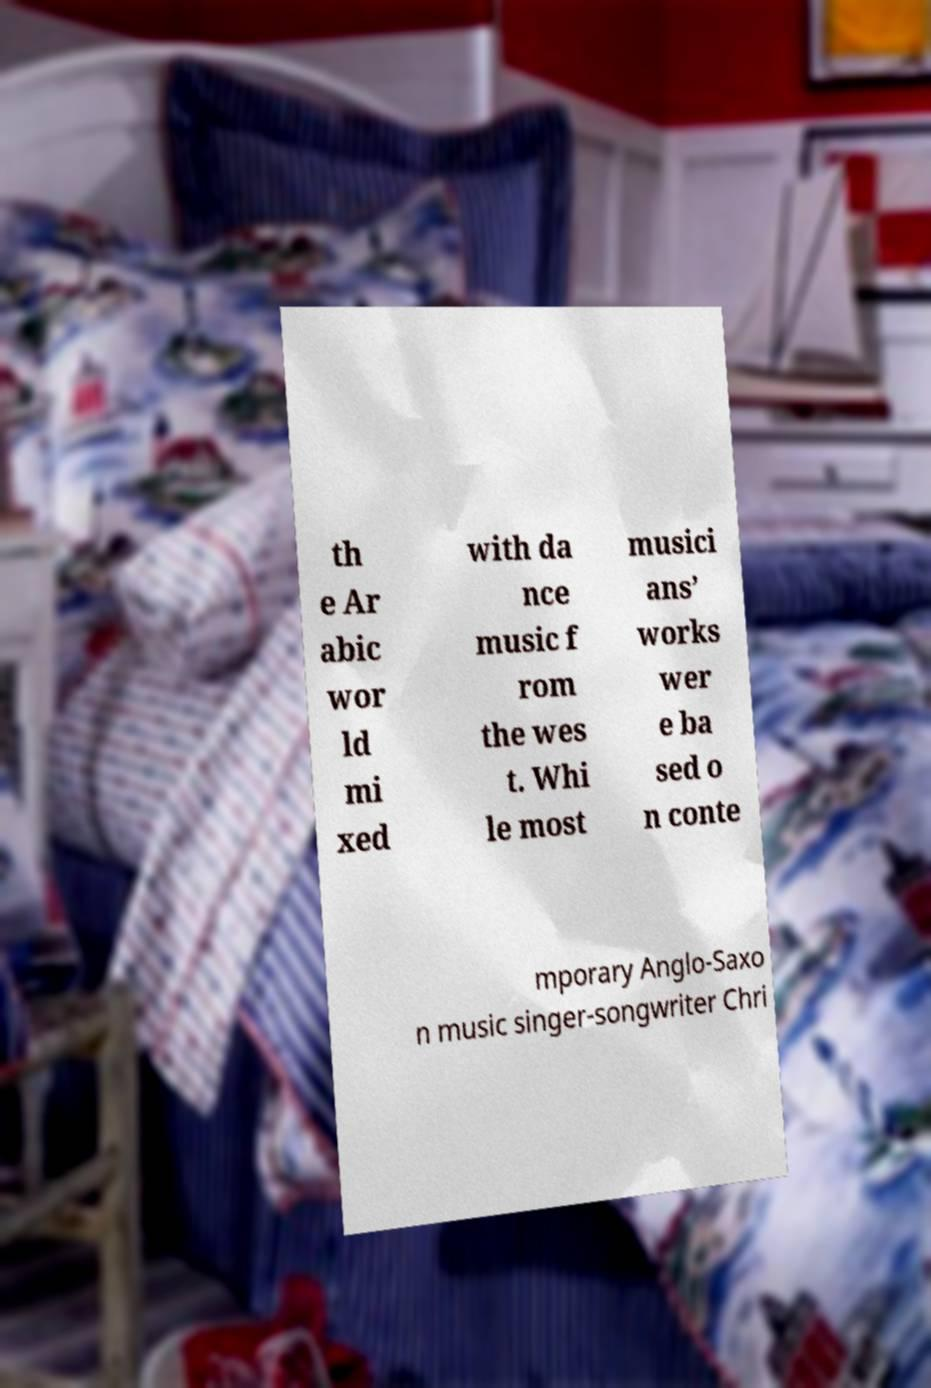Could you assist in decoding the text presented in this image and type it out clearly? th e Ar abic wor ld mi xed with da nce music f rom the wes t. Whi le most musici ans’ works wer e ba sed o n conte mporary Anglo-Saxo n music singer-songwriter Chri 